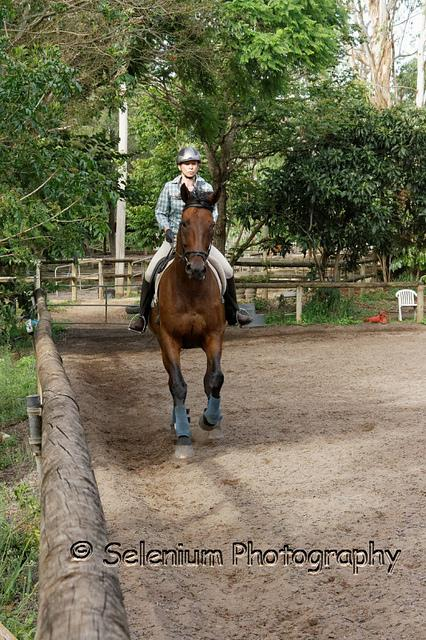In which setting is this person? Please explain your reasoning. farm. The man is riding a horse so a barn must be nearby. 